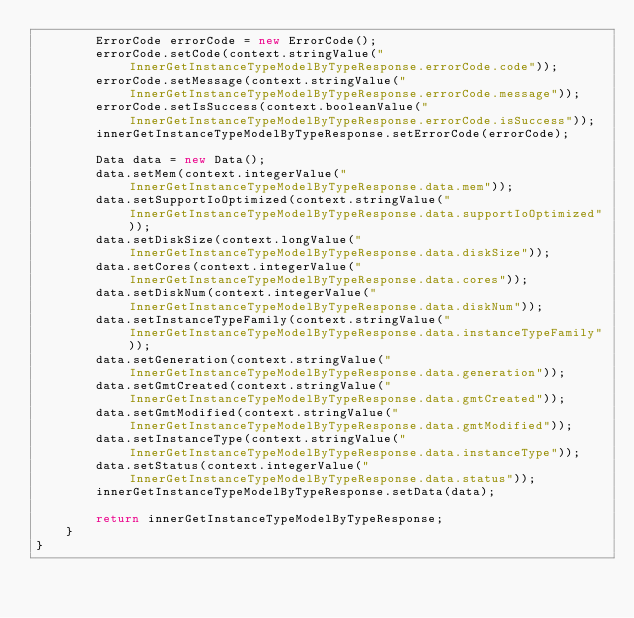Convert code to text. <code><loc_0><loc_0><loc_500><loc_500><_Java_>		ErrorCode errorCode = new ErrorCode();
		errorCode.setCode(context.stringValue("InnerGetInstanceTypeModelByTypeResponse.errorCode.code"));
		errorCode.setMessage(context.stringValue("InnerGetInstanceTypeModelByTypeResponse.errorCode.message"));
		errorCode.setIsSuccess(context.booleanValue("InnerGetInstanceTypeModelByTypeResponse.errorCode.isSuccess"));
		innerGetInstanceTypeModelByTypeResponse.setErrorCode(errorCode);

		Data data = new Data();
		data.setMem(context.integerValue("InnerGetInstanceTypeModelByTypeResponse.data.mem"));
		data.setSupportIoOptimized(context.stringValue("InnerGetInstanceTypeModelByTypeResponse.data.supportIoOptimized"));
		data.setDiskSize(context.longValue("InnerGetInstanceTypeModelByTypeResponse.data.diskSize"));
		data.setCores(context.integerValue("InnerGetInstanceTypeModelByTypeResponse.data.cores"));
		data.setDiskNum(context.integerValue("InnerGetInstanceTypeModelByTypeResponse.data.diskNum"));
		data.setInstanceTypeFamily(context.stringValue("InnerGetInstanceTypeModelByTypeResponse.data.instanceTypeFamily"));
		data.setGeneration(context.stringValue("InnerGetInstanceTypeModelByTypeResponse.data.generation"));
		data.setGmtCreated(context.stringValue("InnerGetInstanceTypeModelByTypeResponse.data.gmtCreated"));
		data.setGmtModified(context.stringValue("InnerGetInstanceTypeModelByTypeResponse.data.gmtModified"));
		data.setInstanceType(context.stringValue("InnerGetInstanceTypeModelByTypeResponse.data.instanceType"));
		data.setStatus(context.integerValue("InnerGetInstanceTypeModelByTypeResponse.data.status"));
		innerGetInstanceTypeModelByTypeResponse.setData(data);
	 
	 	return innerGetInstanceTypeModelByTypeResponse;
	}
}</code> 